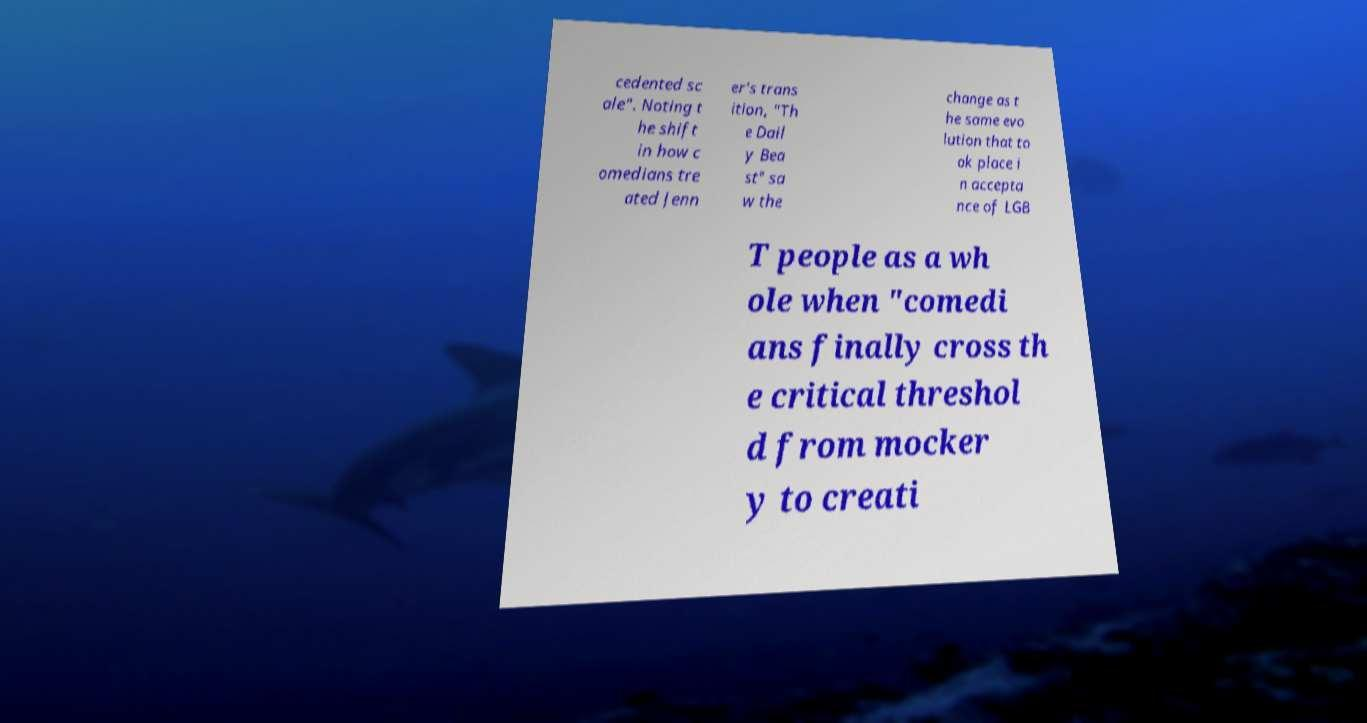Can you read and provide the text displayed in the image?This photo seems to have some interesting text. Can you extract and type it out for me? cedented sc ale". Noting t he shift in how c omedians tre ated Jenn er's trans ition, "Th e Dail y Bea st" sa w the change as t he same evo lution that to ok place i n accepta nce of LGB T people as a wh ole when "comedi ans finally cross th e critical threshol d from mocker y to creati 